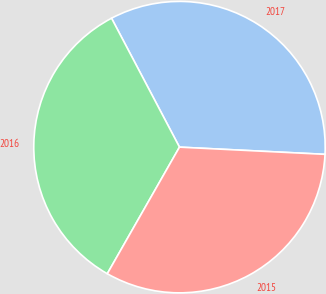<chart> <loc_0><loc_0><loc_500><loc_500><pie_chart><fcel>2017<fcel>2016<fcel>2015<nl><fcel>33.51%<fcel>34.03%<fcel>32.46%<nl></chart> 